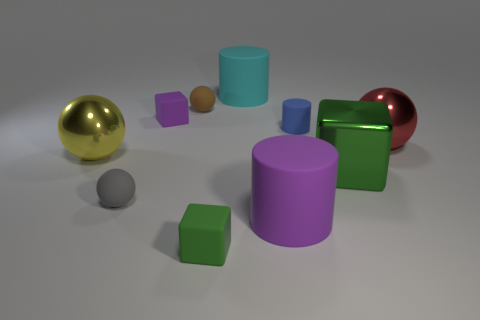Subtract all cyan cylinders. How many cylinders are left? 2 Subtract all cyan cylinders. How many cylinders are left? 2 Subtract all cubes. How many objects are left? 7 Subtract all green cylinders. How many green blocks are left? 2 Add 2 green things. How many green things are left? 4 Add 7 purple matte cubes. How many purple matte cubes exist? 8 Subtract 0 blue blocks. How many objects are left? 10 Subtract 3 cylinders. How many cylinders are left? 0 Subtract all cyan blocks. Subtract all red cylinders. How many blocks are left? 3 Subtract all purple rubber cubes. Subtract all cyan rubber cylinders. How many objects are left? 8 